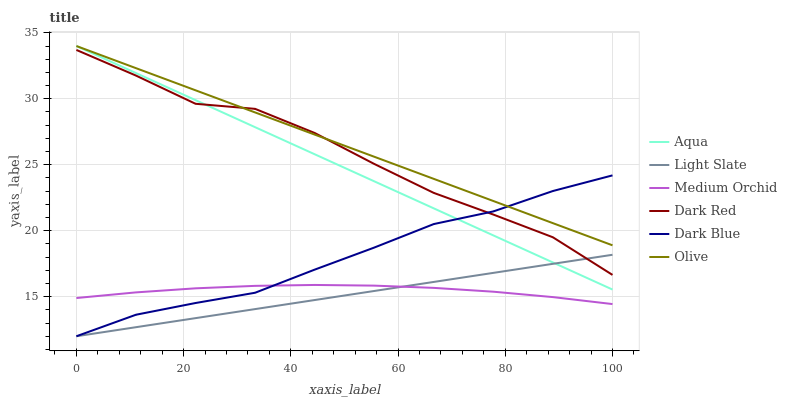Does Light Slate have the minimum area under the curve?
Answer yes or no. Yes. Does Olive have the maximum area under the curve?
Answer yes or no. Yes. Does Dark Red have the minimum area under the curve?
Answer yes or no. No. Does Dark Red have the maximum area under the curve?
Answer yes or no. No. Is Light Slate the smoothest?
Answer yes or no. Yes. Is Dark Red the roughest?
Answer yes or no. Yes. Is Medium Orchid the smoothest?
Answer yes or no. No. Is Medium Orchid the roughest?
Answer yes or no. No. Does Light Slate have the lowest value?
Answer yes or no. Yes. Does Dark Red have the lowest value?
Answer yes or no. No. Does Olive have the highest value?
Answer yes or no. Yes. Does Dark Red have the highest value?
Answer yes or no. No. Is Light Slate less than Olive?
Answer yes or no. Yes. Is Aqua greater than Medium Orchid?
Answer yes or no. Yes. Does Dark Blue intersect Dark Red?
Answer yes or no. Yes. Is Dark Blue less than Dark Red?
Answer yes or no. No. Is Dark Blue greater than Dark Red?
Answer yes or no. No. Does Light Slate intersect Olive?
Answer yes or no. No. 